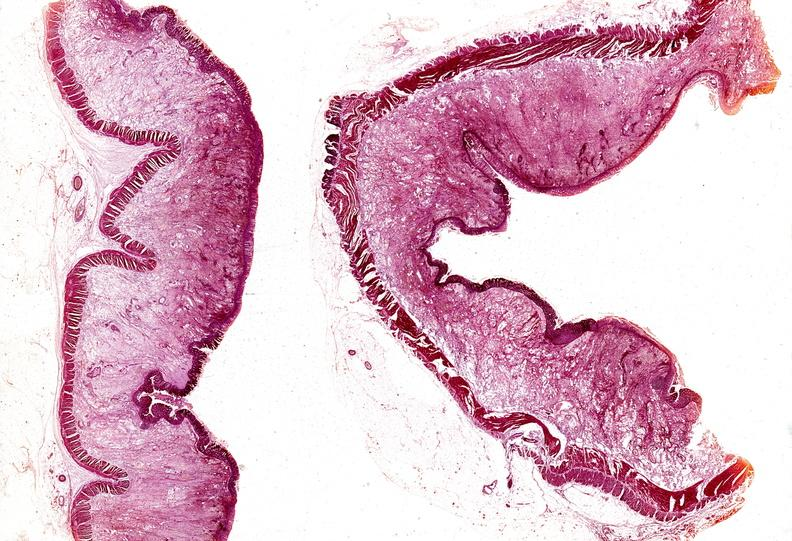s normal newborn present?
Answer the question using a single word or phrase. No 